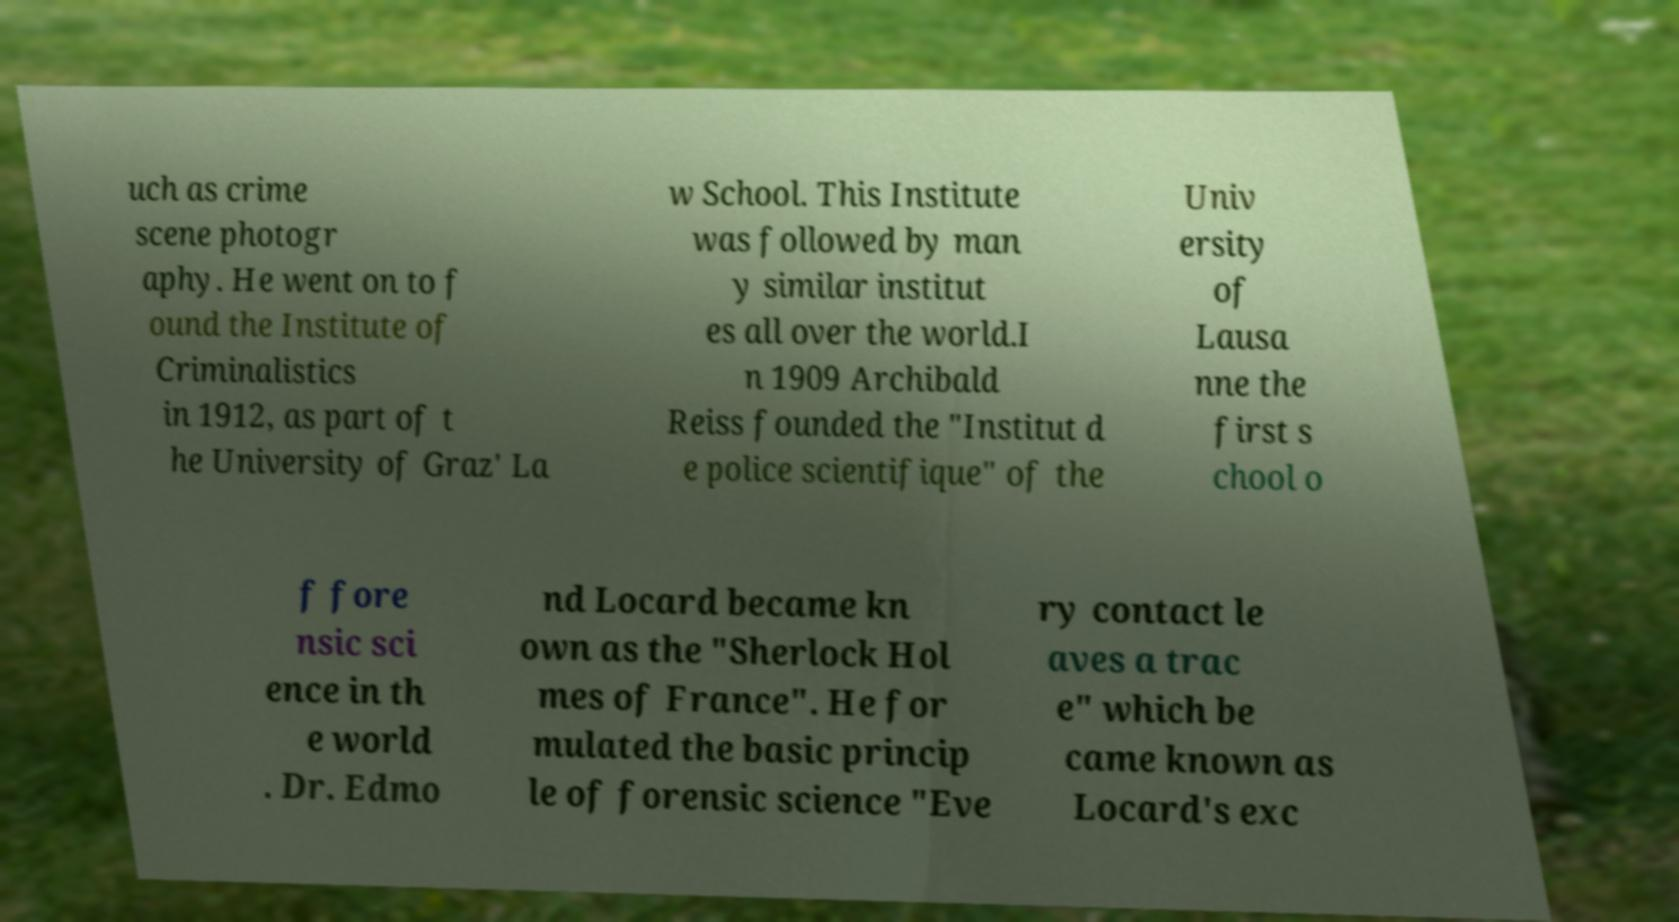Could you assist in decoding the text presented in this image and type it out clearly? uch as crime scene photogr aphy. He went on to f ound the Institute of Criminalistics in 1912, as part of t he University of Graz' La w School. This Institute was followed by man y similar institut es all over the world.I n 1909 Archibald Reiss founded the "Institut d e police scientifique" of the Univ ersity of Lausa nne the first s chool o f fore nsic sci ence in th e world . Dr. Edmo nd Locard became kn own as the "Sherlock Hol mes of France". He for mulated the basic princip le of forensic science "Eve ry contact le aves a trac e" which be came known as Locard's exc 